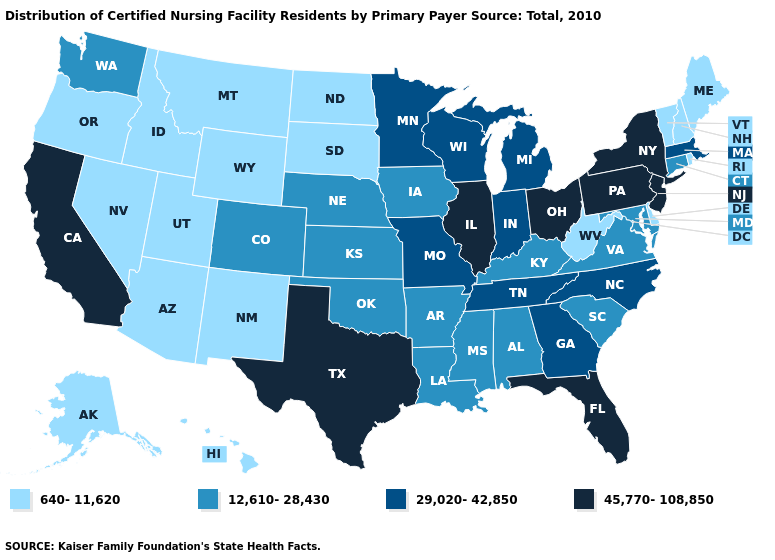Does Oklahoma have a lower value than Georgia?
Be succinct. Yes. What is the value of West Virginia?
Give a very brief answer. 640-11,620. Is the legend a continuous bar?
Keep it brief. No. Does the first symbol in the legend represent the smallest category?
Write a very short answer. Yes. Name the states that have a value in the range 640-11,620?
Answer briefly. Alaska, Arizona, Delaware, Hawaii, Idaho, Maine, Montana, Nevada, New Hampshire, New Mexico, North Dakota, Oregon, Rhode Island, South Dakota, Utah, Vermont, West Virginia, Wyoming. What is the lowest value in states that border New Hampshire?
Give a very brief answer. 640-11,620. Name the states that have a value in the range 45,770-108,850?
Be succinct. California, Florida, Illinois, New Jersey, New York, Ohio, Pennsylvania, Texas. Name the states that have a value in the range 45,770-108,850?
Concise answer only. California, Florida, Illinois, New Jersey, New York, Ohio, Pennsylvania, Texas. What is the value of Missouri?
Write a very short answer. 29,020-42,850. Does Connecticut have the lowest value in the Northeast?
Quick response, please. No. Name the states that have a value in the range 640-11,620?
Answer briefly. Alaska, Arizona, Delaware, Hawaii, Idaho, Maine, Montana, Nevada, New Hampshire, New Mexico, North Dakota, Oregon, Rhode Island, South Dakota, Utah, Vermont, West Virginia, Wyoming. What is the value of Tennessee?
Write a very short answer. 29,020-42,850. Name the states that have a value in the range 12,610-28,430?
Answer briefly. Alabama, Arkansas, Colorado, Connecticut, Iowa, Kansas, Kentucky, Louisiana, Maryland, Mississippi, Nebraska, Oklahoma, South Carolina, Virginia, Washington. Which states hav the highest value in the Northeast?
Quick response, please. New Jersey, New York, Pennsylvania. Name the states that have a value in the range 640-11,620?
Give a very brief answer. Alaska, Arizona, Delaware, Hawaii, Idaho, Maine, Montana, Nevada, New Hampshire, New Mexico, North Dakota, Oregon, Rhode Island, South Dakota, Utah, Vermont, West Virginia, Wyoming. 